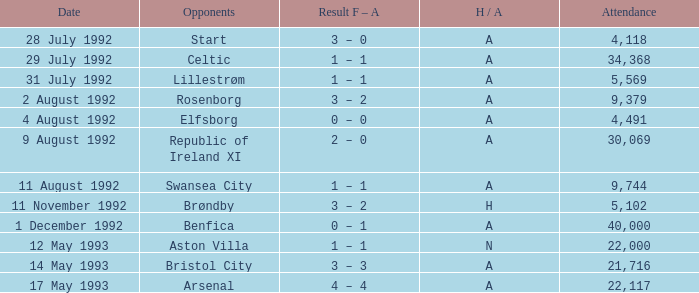Which Result F-A has Opponents of rosenborg? 3 – 2. 